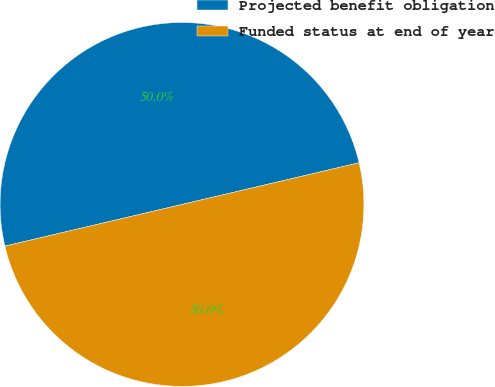Convert chart to OTSL. <chart><loc_0><loc_0><loc_500><loc_500><pie_chart><fcel>Projected benefit obligation<fcel>Funded status at end of year<nl><fcel>50.0%<fcel>50.0%<nl></chart> 